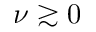Convert formula to latex. <formula><loc_0><loc_0><loc_500><loc_500>\nu \gtrsim 0</formula> 